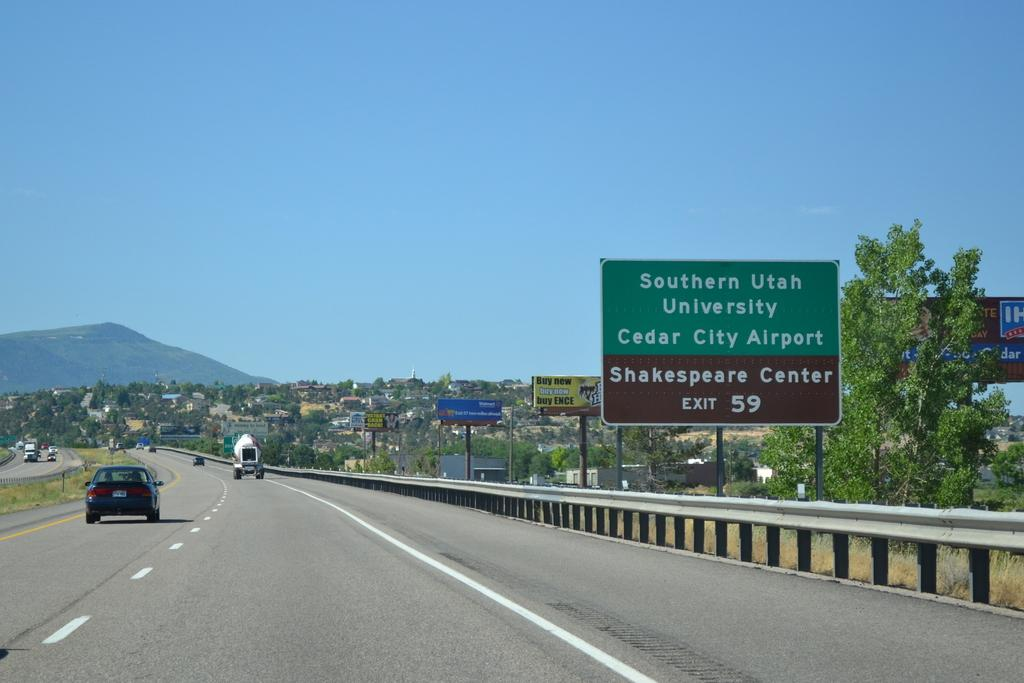Provide a one-sentence caption for the provided image. Cars driving through a highway with a green road sign displaying an exit for Southern Utah University. 